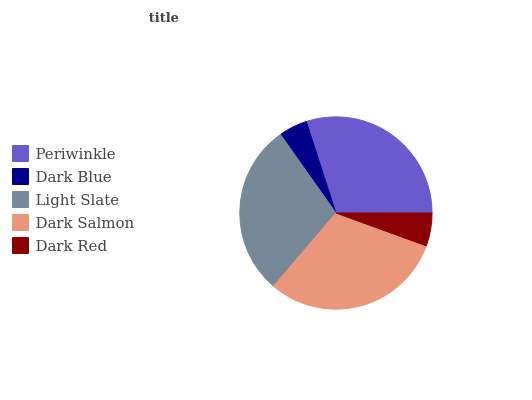Is Dark Blue the minimum?
Answer yes or no. Yes. Is Dark Salmon the maximum?
Answer yes or no. Yes. Is Light Slate the minimum?
Answer yes or no. No. Is Light Slate the maximum?
Answer yes or no. No. Is Light Slate greater than Dark Blue?
Answer yes or no. Yes. Is Dark Blue less than Light Slate?
Answer yes or no. Yes. Is Dark Blue greater than Light Slate?
Answer yes or no. No. Is Light Slate less than Dark Blue?
Answer yes or no. No. Is Light Slate the high median?
Answer yes or no. Yes. Is Light Slate the low median?
Answer yes or no. Yes. Is Dark Blue the high median?
Answer yes or no. No. Is Dark Blue the low median?
Answer yes or no. No. 